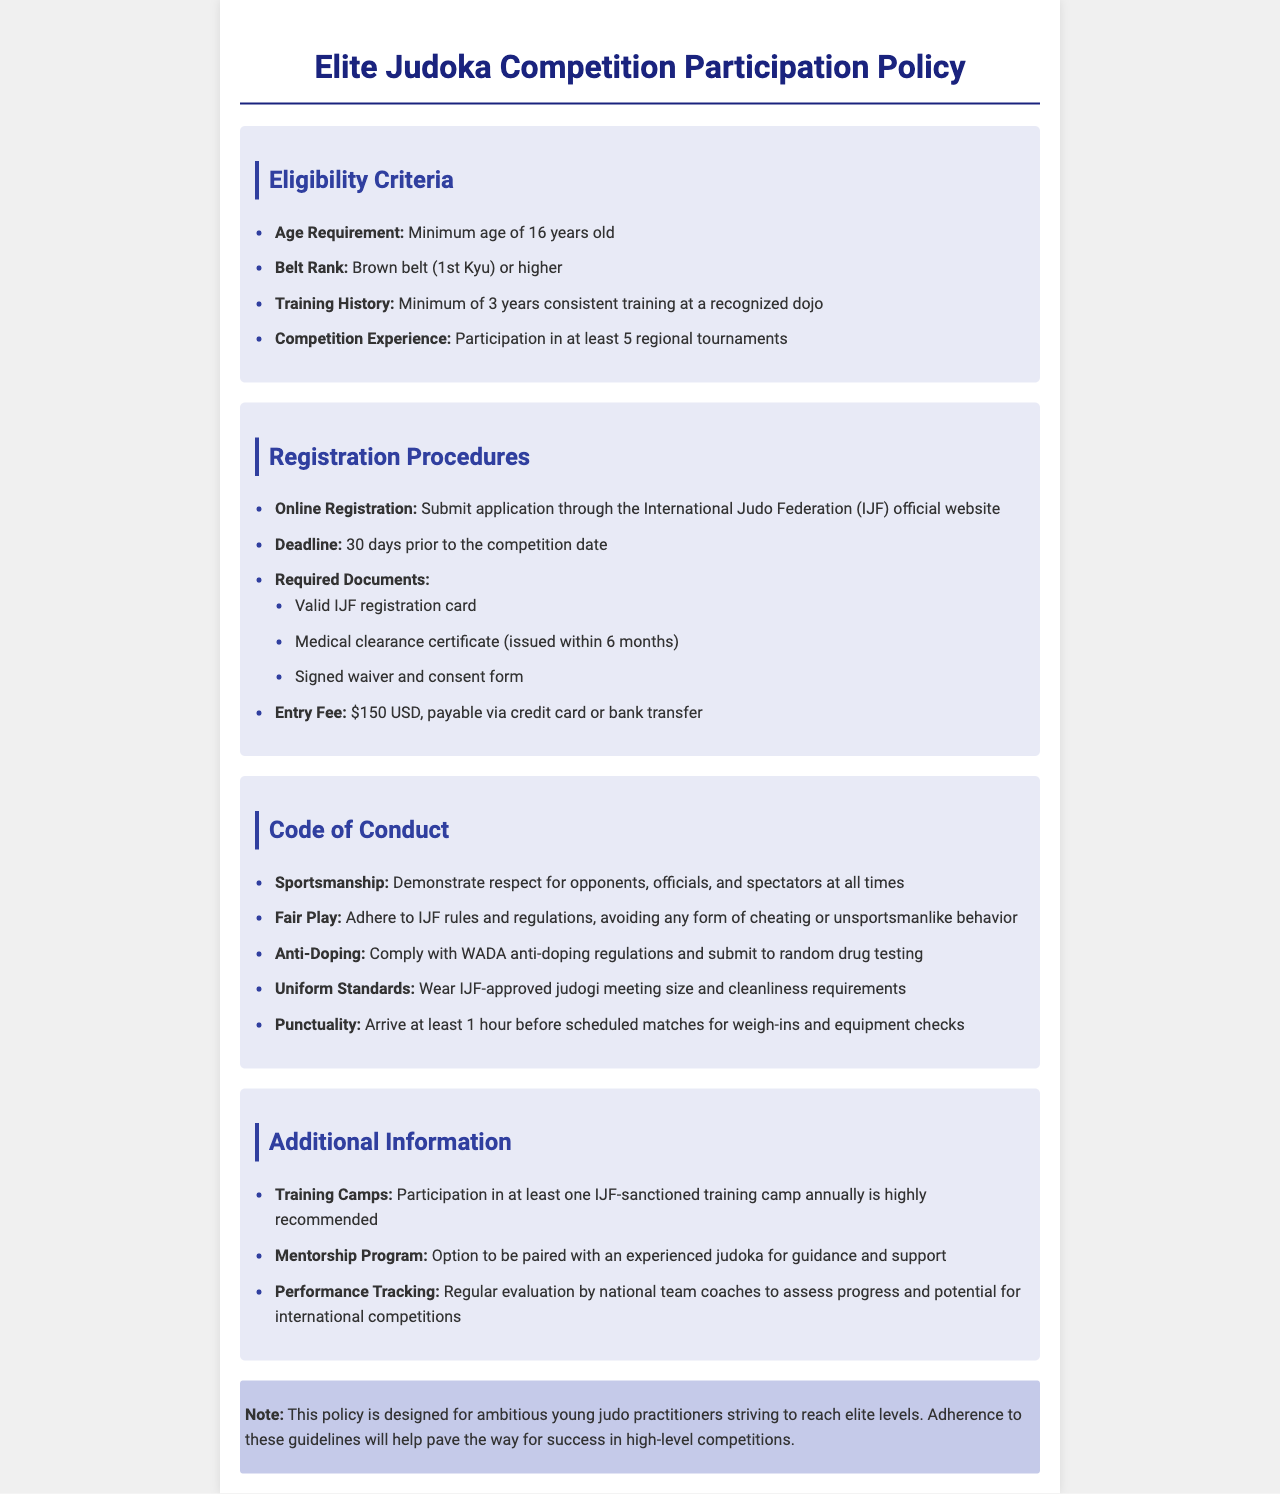What is the minimum age requirement for competition participation? The minimum age requirement is mentioned under the Eligibility Criteria section of the document.
Answer: 16 years old What belt rank is required to participate? The required belt rank is specified in the Eligibility Criteria section.
Answer: Brown belt (1st Kyu) or higher How many regional tournaments must a judoka have participated in? This information is found in the Eligibility Criteria section which outlines competition experience requirements.
Answer: At least 5 regional tournaments What is the registration deadline for competitions? The registration deadline is detailed in the Registration Procedures section.
Answer: 30 days prior to the competition date What is the entry fee for participation? The entry fee is listed as a specific dollar amount in the Registration Procedures section.
Answer: $150 USD What document must be submitted within 6 months of the competition? This document is required as part of the registration process and is mentioned in the Required Documents list.
Answer: Medical clearance certificate What is required of participants in terms of sportsmanship? The Code of Conduct highlights expectations regarding behavior towards others in competition.
Answer: Demonstrate respect for opponents, officials, and spectators at all times How early should participants arrive before scheduled matches? This information is included in the Code of Conduct section and indicates punctuality expectations.
Answer: At least 1 hour What mentorship option is available? The Additional Information section provides details on support options available to participants.
Answer: Option to be paired with an experienced judoka for guidance and support 